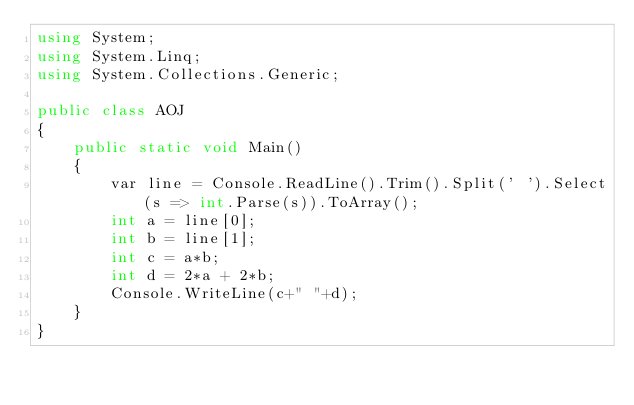<code> <loc_0><loc_0><loc_500><loc_500><_C#_>using System;
using System.Linq;
using System.Collections.Generic;

public class AOJ
{
    public static void Main()
    {
        var line = Console.ReadLine().Trim().Split(' ').Select(s => int.Parse(s)).ToArray();
        int a = line[0];
        int b = line[1];
        int c = a*b;
        int d = 2*a + 2*b;
        Console.WriteLine(c+" "+d);
    }
}
</code> 